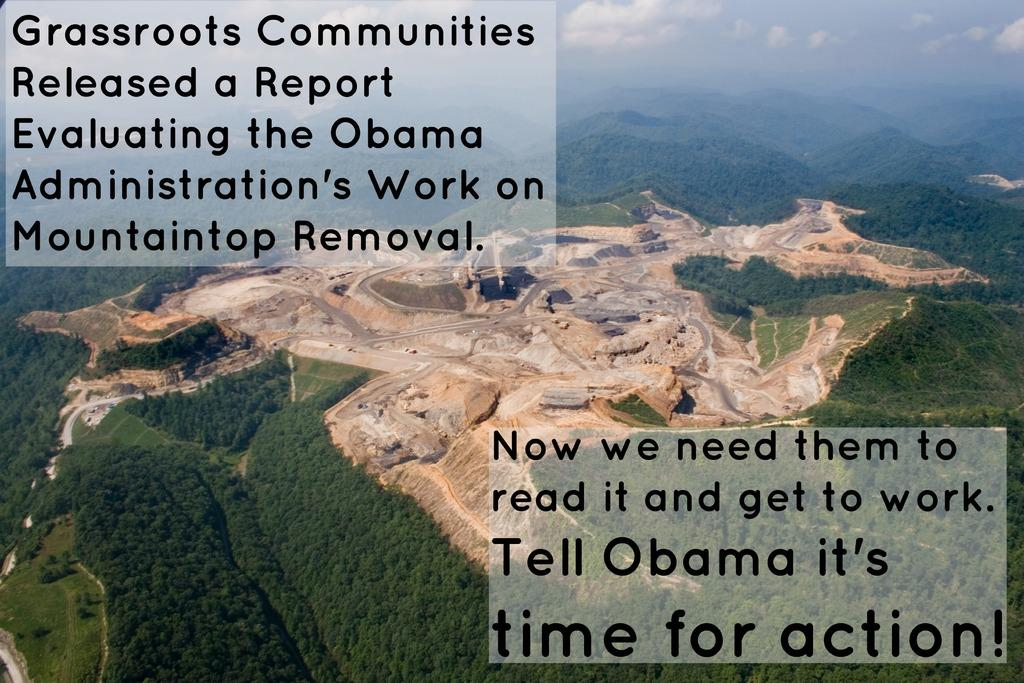What type of landscape is depicted in the image? The image features hills. What can be found on the hills in the image? There are stones on the hills. What type of vegetation is present in the image? There are green trees in the image. Is there any text visible in the image? Yes, there is text in the image. What type of sugar is being used to sweeten the weather in the image? There is no sugar or weather mentioned in the image; it features hills, stones, green trees, and text. 